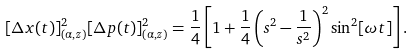<formula> <loc_0><loc_0><loc_500><loc_500>[ \Delta x ( t ) ] ^ { 2 } _ { ( \alpha , z ) } [ \Delta p ( t ) ] ^ { 2 } _ { ( \alpha , z ) } = \frac { 1 } { 4 } \left [ 1 + \frac { 1 } { 4 } \left ( s ^ { 2 } - \frac { 1 } { s ^ { 2 } } \right ) ^ { 2 } \sin ^ { 2 } [ \omega t ] \right ] .</formula> 